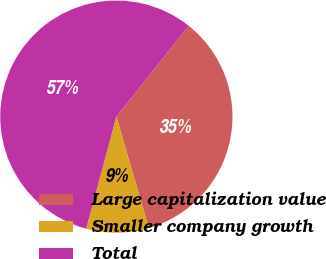<chart> <loc_0><loc_0><loc_500><loc_500><pie_chart><fcel>Large capitalization value<fcel>Smaller company growth<fcel>Total<nl><fcel>34.78%<fcel>8.7%<fcel>56.52%<nl></chart> 